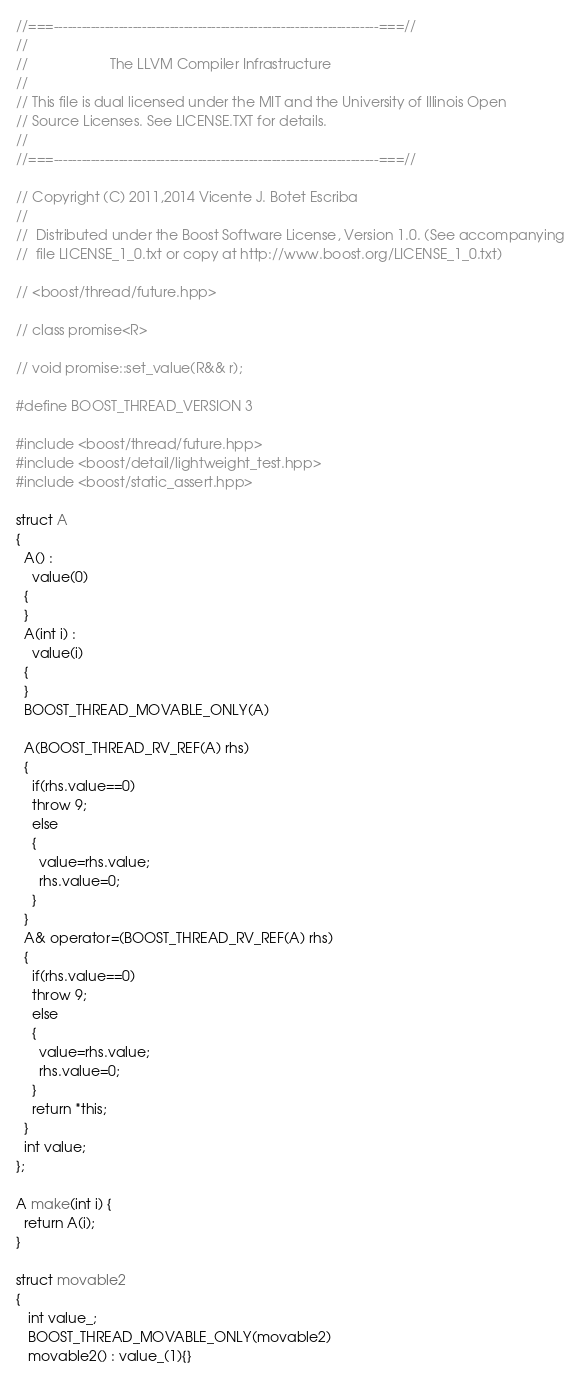Convert code to text. <code><loc_0><loc_0><loc_500><loc_500><_C++_>//===----------------------------------------------------------------------===//
//
//                     The LLVM Compiler Infrastructure
//
// This file is dual licensed under the MIT and the University of Illinois Open
// Source Licenses. See LICENSE.TXT for details.
//
//===----------------------------------------------------------------------===//

// Copyright (C) 2011,2014 Vicente J. Botet Escriba
//
//  Distributed under the Boost Software License, Version 1.0. (See accompanying
//  file LICENSE_1_0.txt or copy at http://www.boost.org/LICENSE_1_0.txt)

// <boost/thread/future.hpp>

// class promise<R>

// void promise::set_value(R&& r);

#define BOOST_THREAD_VERSION 3

#include <boost/thread/future.hpp>
#include <boost/detail/lightweight_test.hpp>
#include <boost/static_assert.hpp>

struct A
{
  A() :
    value(0)
  {
  }
  A(int i) :
    value(i)
  {
  }
  BOOST_THREAD_MOVABLE_ONLY(A)

  A(BOOST_THREAD_RV_REF(A) rhs)
  {
    if(rhs.value==0)
    throw 9;
    else
    {
      value=rhs.value;
      rhs.value=0;
    }
  }
  A& operator=(BOOST_THREAD_RV_REF(A) rhs)
  {
    if(rhs.value==0)
    throw 9;
    else
    {
      value=rhs.value;
      rhs.value=0;
    }
    return *this;
  }
  int value;
};

A make(int i) {
  return A(i);
}

struct movable2
{
   int value_;
   BOOST_THREAD_MOVABLE_ONLY(movable2)
   movable2() : value_(1){}</code> 